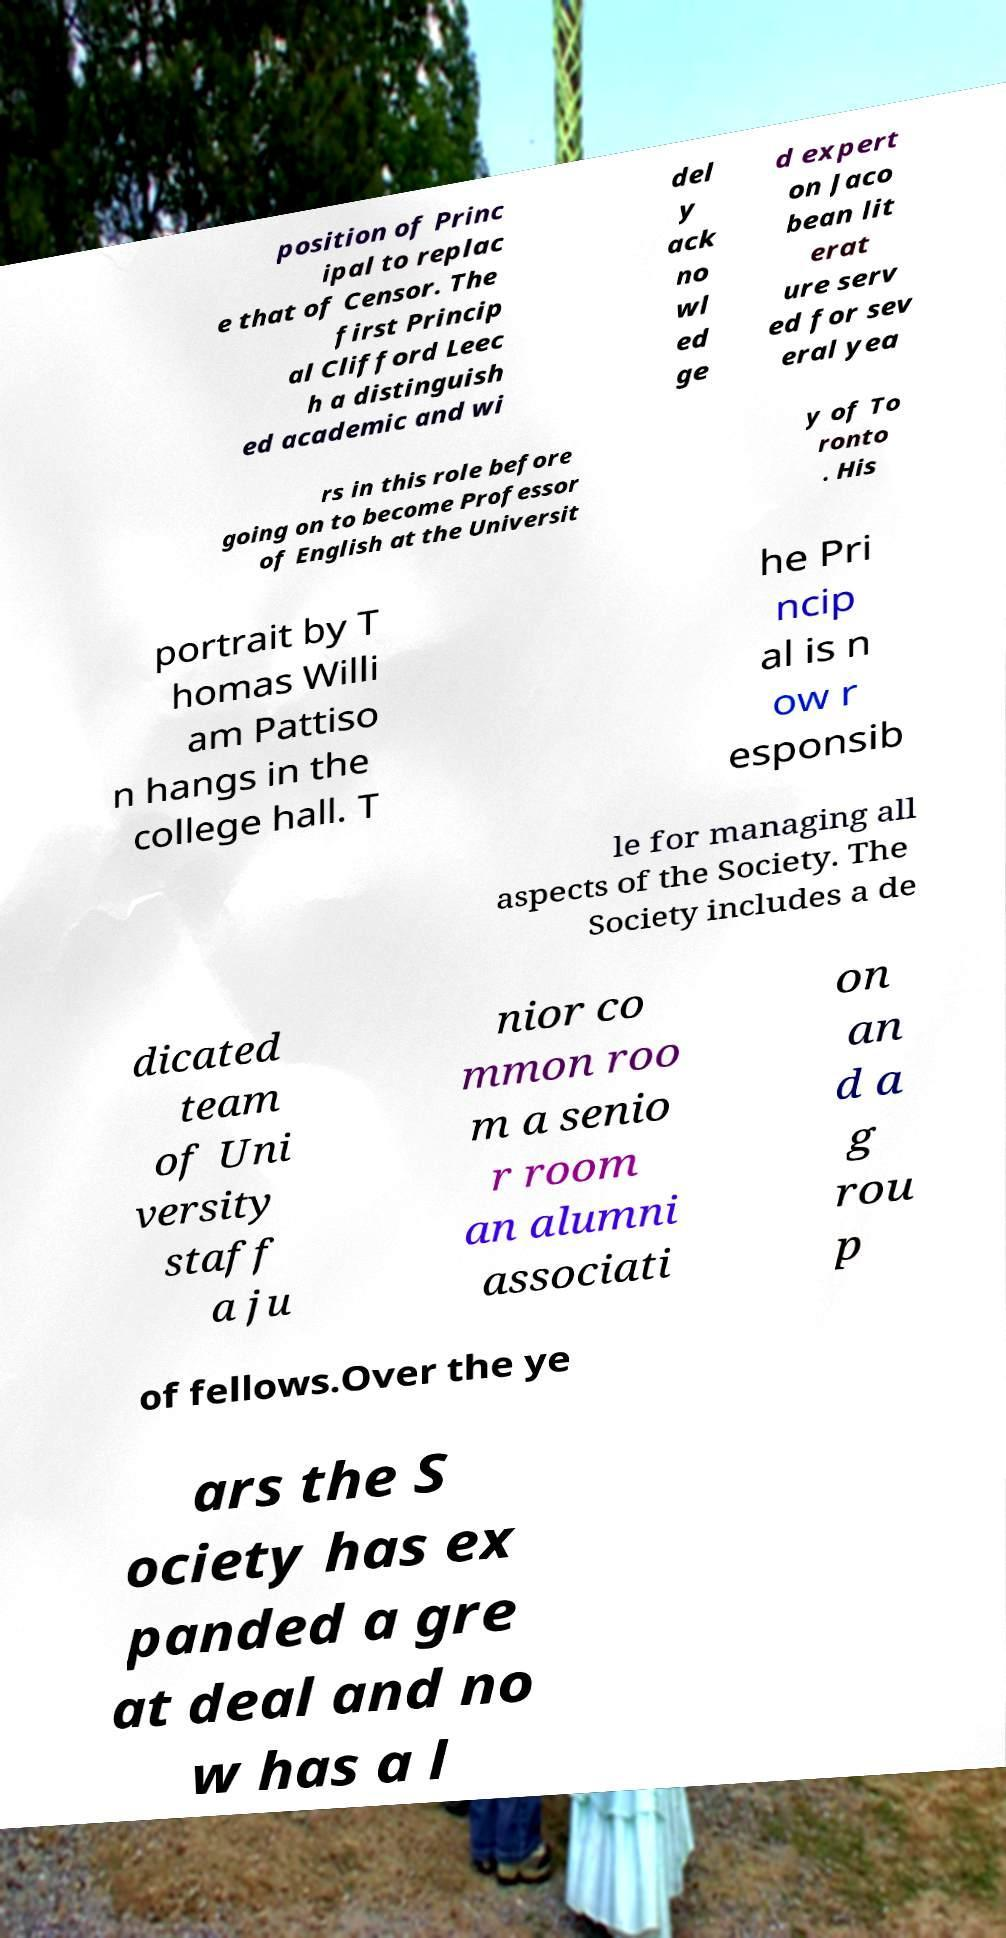Please identify and transcribe the text found in this image. position of Princ ipal to replac e that of Censor. The first Princip al Clifford Leec h a distinguish ed academic and wi del y ack no wl ed ge d expert on Jaco bean lit erat ure serv ed for sev eral yea rs in this role before going on to become Professor of English at the Universit y of To ronto . His portrait by T homas Willi am Pattiso n hangs in the college hall. T he Pri ncip al is n ow r esponsib le for managing all aspects of the Society. The Society includes a de dicated team of Uni versity staff a ju nior co mmon roo m a senio r room an alumni associati on an d a g rou p of fellows.Over the ye ars the S ociety has ex panded a gre at deal and no w has a l 